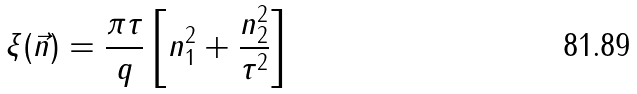<formula> <loc_0><loc_0><loc_500><loc_500>\xi ( \vec { n } ) = \frac { \pi \tau } { q } \left [ n _ { 1 } ^ { 2 } + \frac { n _ { 2 } ^ { 2 } } { \tau ^ { 2 } } \right ]</formula> 